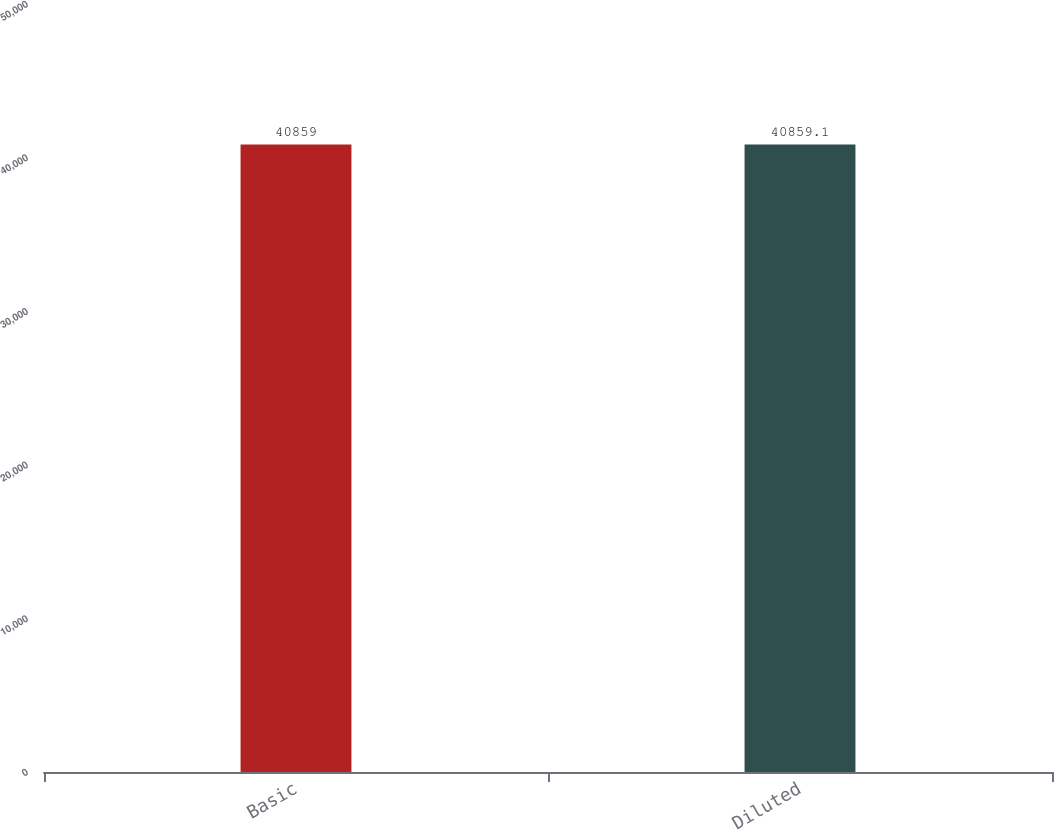<chart> <loc_0><loc_0><loc_500><loc_500><bar_chart><fcel>Basic<fcel>Diluted<nl><fcel>40859<fcel>40859.1<nl></chart> 